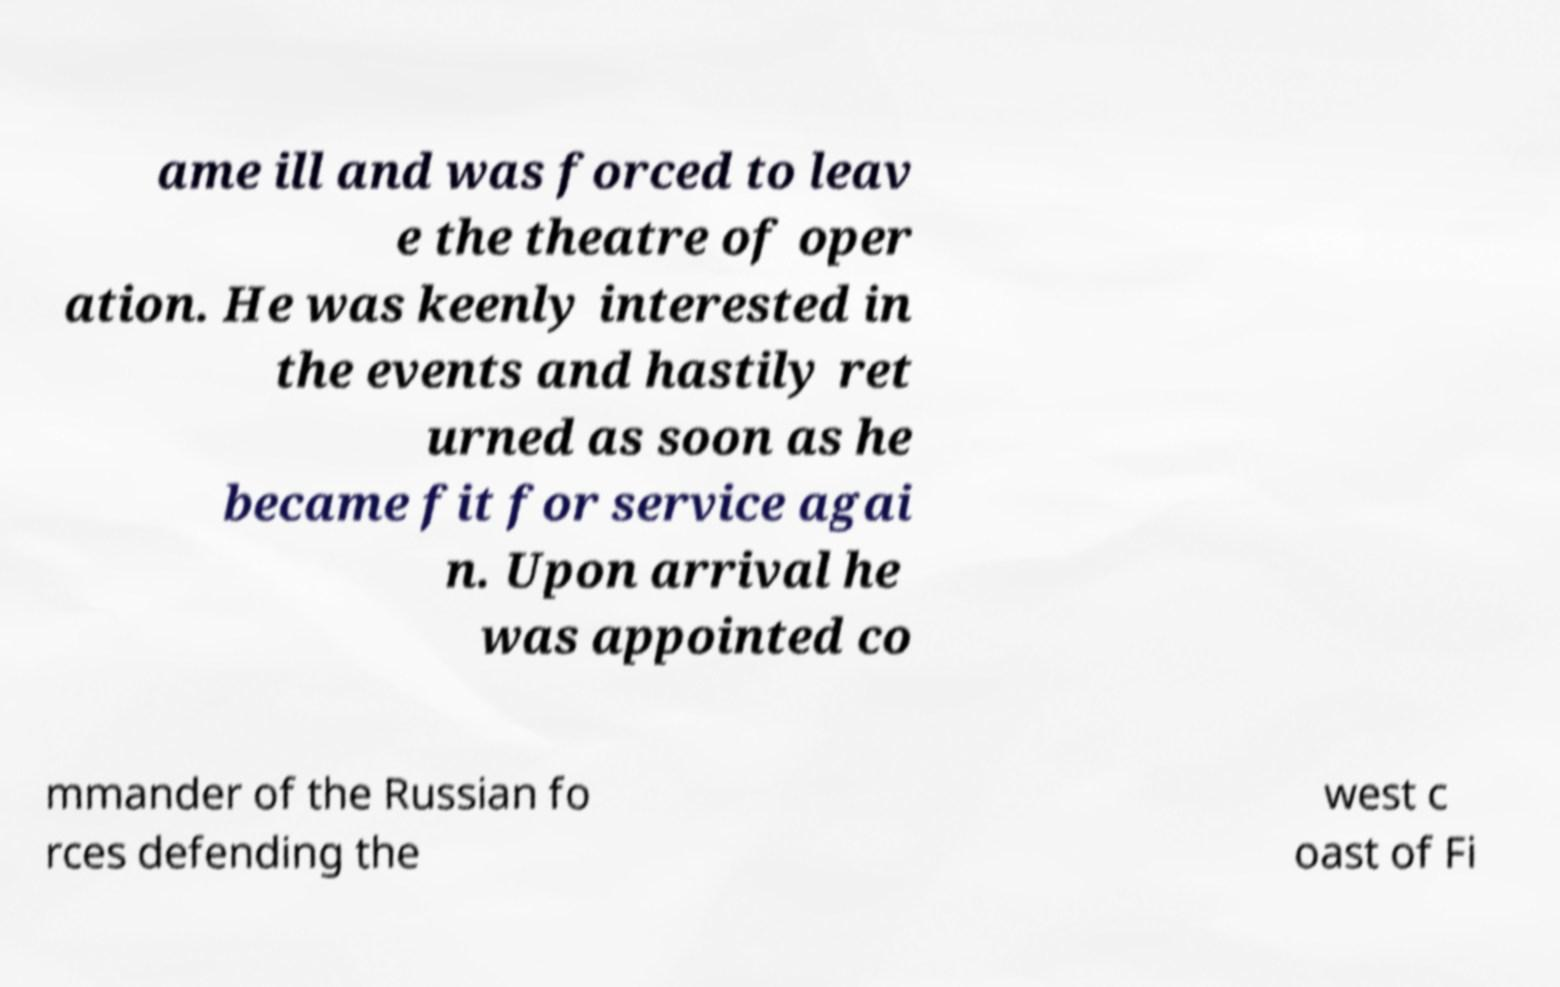For documentation purposes, I need the text within this image transcribed. Could you provide that? ame ill and was forced to leav e the theatre of oper ation. He was keenly interested in the events and hastily ret urned as soon as he became fit for service agai n. Upon arrival he was appointed co mmander of the Russian fo rces defending the west c oast of Fi 